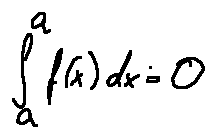<formula> <loc_0><loc_0><loc_500><loc_500>\int \lim i t s _ { a } ^ { a } f ( x ) d x = 0</formula> 